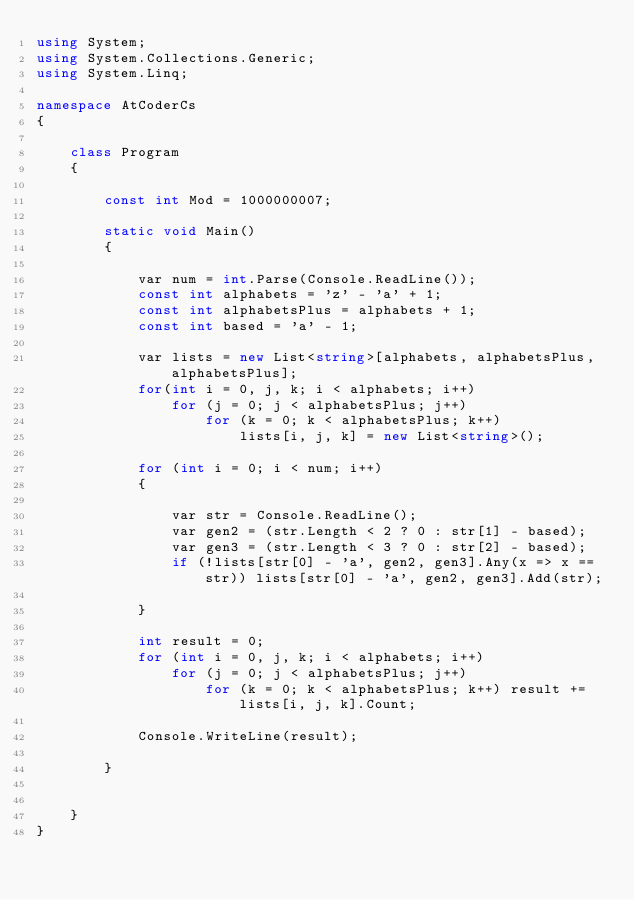Convert code to text. <code><loc_0><loc_0><loc_500><loc_500><_C#_>using System;
using System.Collections.Generic;
using System.Linq;

namespace AtCoderCs
{

    class Program
    {

        const int Mod = 1000000007;

        static void Main()
        {

            var num = int.Parse(Console.ReadLine());
            const int alphabets = 'z' - 'a' + 1;
            const int alphabetsPlus = alphabets + 1;
            const int based = 'a' - 1;

            var lists = new List<string>[alphabets, alphabetsPlus, alphabetsPlus];
            for(int i = 0, j, k; i < alphabets; i++)
                for (j = 0; j < alphabetsPlus; j++)
                    for (k = 0; k < alphabetsPlus; k++)
                        lists[i, j, k] = new List<string>();

            for (int i = 0; i < num; i++)
            {

                var str = Console.ReadLine();
                var gen2 = (str.Length < 2 ? 0 : str[1] - based);
                var gen3 = (str.Length < 3 ? 0 : str[2] - based);
                if (!lists[str[0] - 'a', gen2, gen3].Any(x => x == str)) lists[str[0] - 'a', gen2, gen3].Add(str);

            }

            int result = 0;
            for (int i = 0, j, k; i < alphabets; i++)
                for (j = 0; j < alphabetsPlus; j++)
                    for (k = 0; k < alphabetsPlus; k++) result += lists[i, j, k].Count;

            Console.WriteLine(result);

        }


    }
}
</code> 